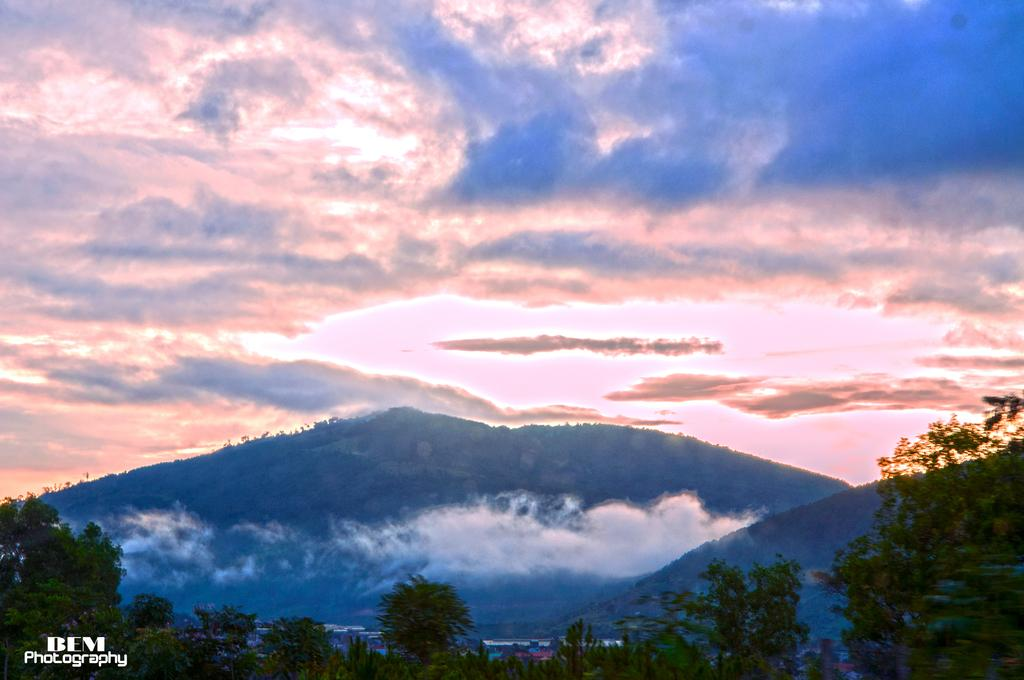What type of natural vegetation can be seen in the image? There are trees in the image. What type of geographical feature is visible in the background of the image? There are mountains visible in the background of the image. What part of the natural environment is visible in the image? The sky is visible in the image. What is the condition of the sky in the image? Clouds are present in the sky. Can you tell me how many pumpkins are on the wall in the image? There is no wall or pumpkins present in the image. 